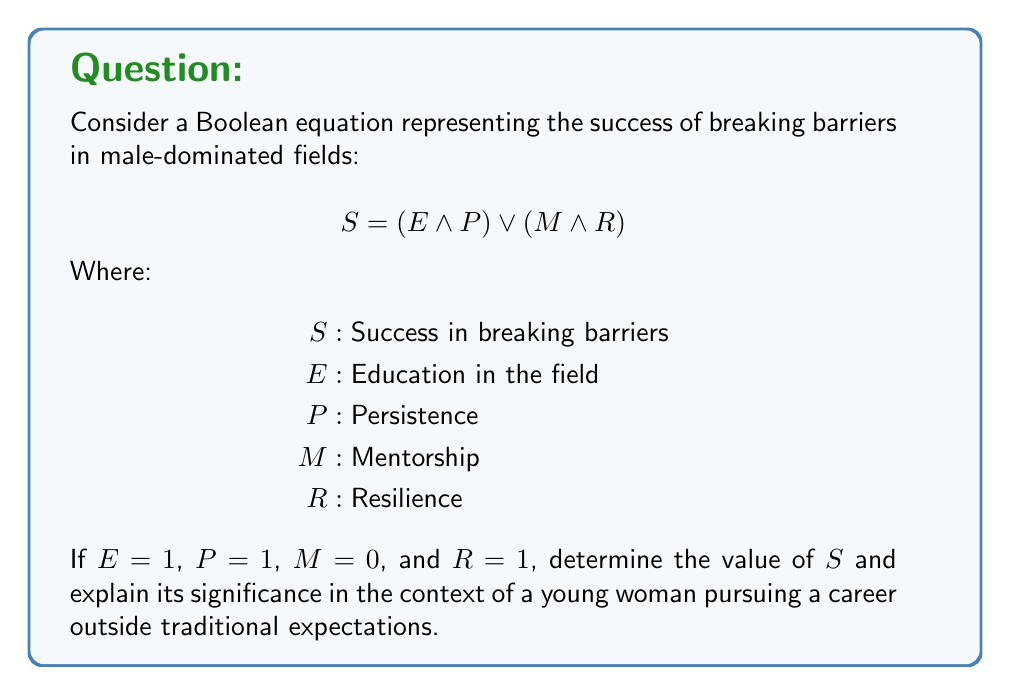Could you help me with this problem? Let's solve this step-by-step:

1) We're given the Boolean equation:
   $S = (E \land P) \lor (M \land R)$

2) We're also given the following values:
   $E = 1$
   $P = 1$
   $M = 0$
   $R = 1$

3) Let's substitute these values into the equation:
   $S = (1 \land 1) \lor (0 \land 1)$

4) Solve the AND operations first:
   $S = (1) \lor (0)$

5) Now solve the OR operation:
   $S = 1$

6) Significance:
   The result $S = 1$ (true) indicates success in breaking barriers. This outcome is achieved even though mentorship (M) is absent (0), demonstrating that education (E) and persistence (P) together can lead to success. It shows that a young woman can overcome societal expectations and succeed in a male-dominated field through education and persistence, even without traditional mentorship. The resilience (R) factor, while present, doesn't affect the outcome in this case due to the lack of mentorship.
Answer: $S = 1$ 